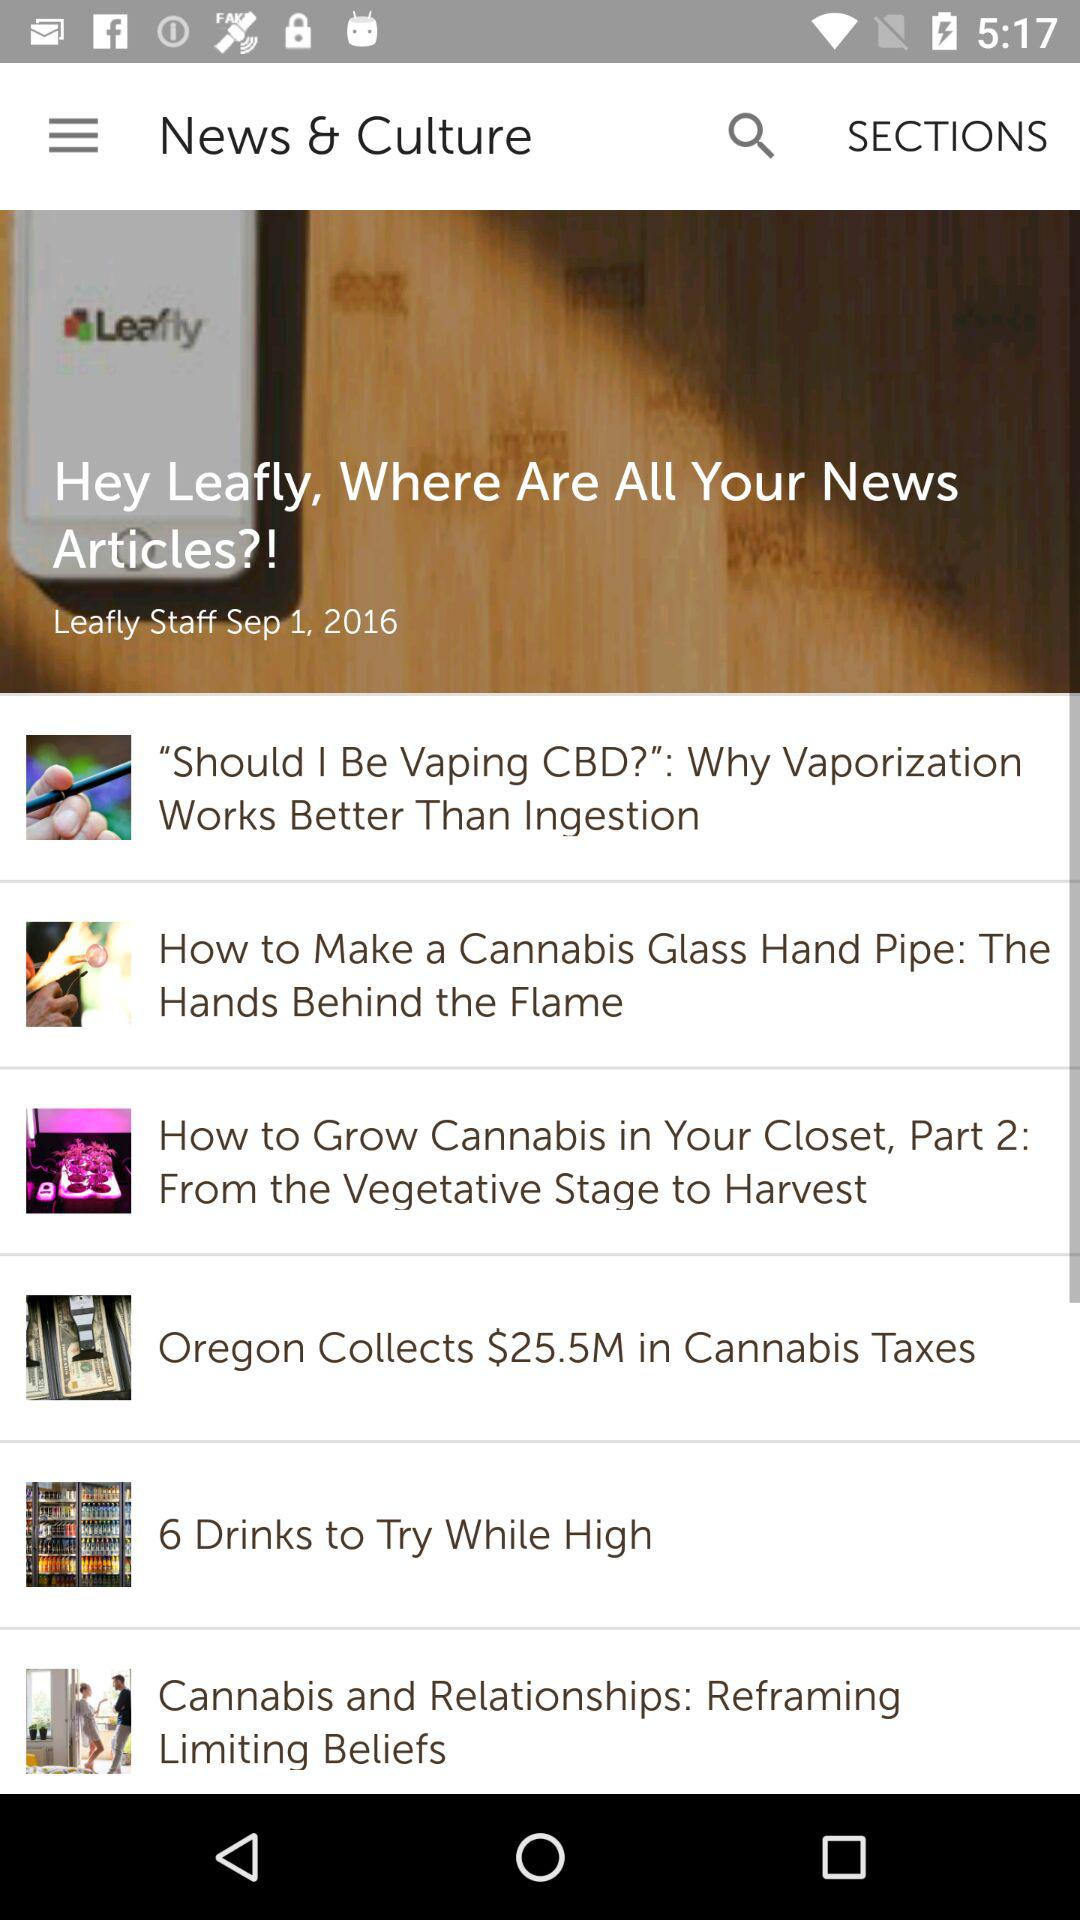What is the application name?
When the provided information is insufficient, respond with <no answer>. <no answer> 